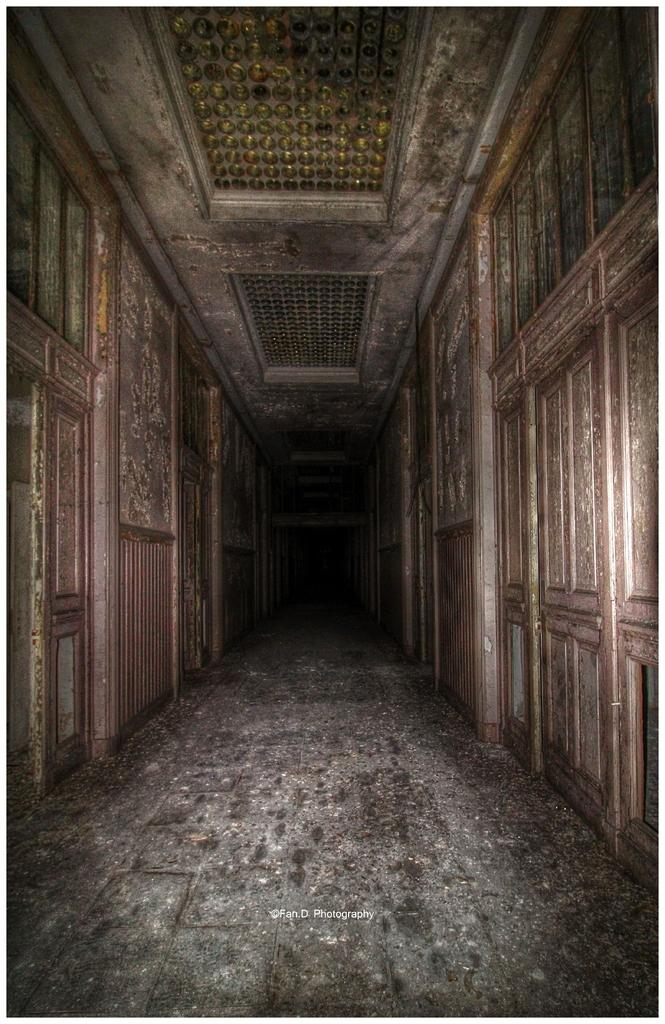What type of view is shown in the image? The image is an inside view of a building. Can you describe any additional features of the image? There is a watermark on the image. What type of wood is used for the government building's exterior in the image? There is no government building or wood visible in the image; it is an inside view of a building with a watermark. 